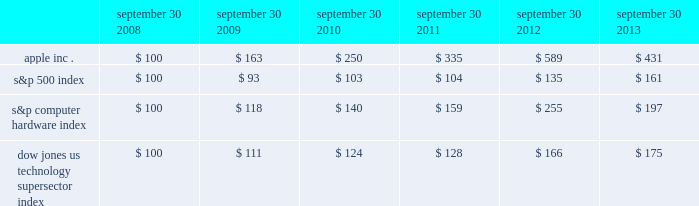Table of contents company stock performance the following graph shows a five-year comparison of cumulative total shareholder return , calculated on a dividend reinvested basis , for the company , the s&p 500 index , the s&p computer hardware index , and the dow jones u.s .
Technology supersector index .
The graph assumes $ 100 was invested in each of the company 2019s common stock , the s&p 500 index , the s&p computer hardware index , and the dow jones u.s .
Technology supersector index as of the market close on september 30 , 2008 .
Data points on the graph are annual .
Note that historic stock price performance is not necessarily indicative of future stock price performance .
Fiscal year ending september 30 .
Copyright 2013 s&p , a division of the mcgraw-hill companies inc .
All rights reserved .
Copyright 2013 dow jones & co .
All rights reserved .
*$ 100 invested on 9/30/08 in stock or index , including reinvestment of dividends .
September 30 , september 30 , september 30 , september 30 , september 30 , september 30 .

By how much did apple inc . outperform the s&p computer hardware index over the above mentioned 6 year period? 
Computations: (((431 - 100) / 100) - ((197 - 100) / 100))
Answer: 2.34. 